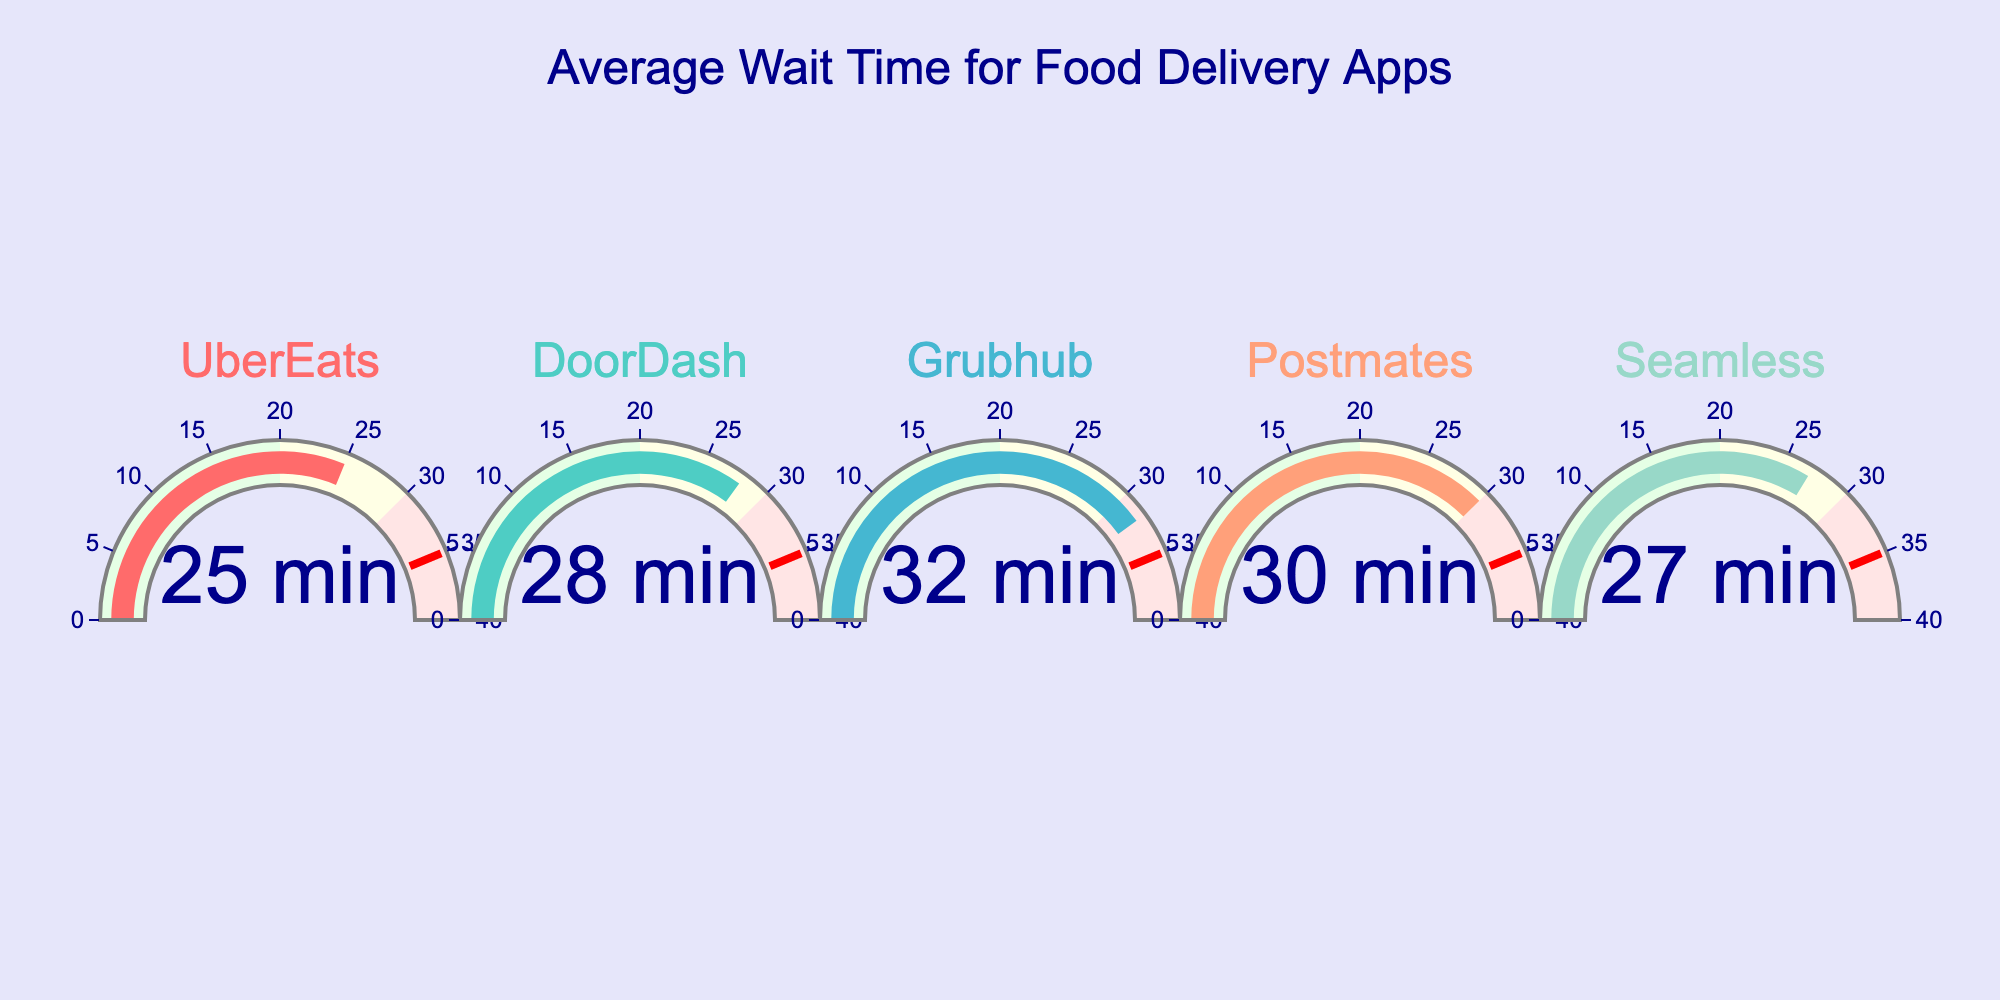What's the highest average wait time among the food delivery apps? The highest average wait time is the topmost number in the gauge chart. From the chart, Grubhub has the highest wait time at 32 minutes.
Answer: 32 minutes What's the average wait time for UberEats? The gauge chart shows the time directly. UberEats has an average wait time of 25 minutes.
Answer: 25 minutes Which app has the lowest average wait time? By comparing all the average wait times displayed on the gauges, UberEats has the lowest average wait time at 25 minutes.
Answer: UberEats How much longer is DoorDash's average wait time compared to Seamless? DoorDash has an average wait time of 28 minutes, and Seamless has an average wait time of 27 minutes. The difference is 28 - 27 = 1 minute.
Answer: 1 minute Is Grubhub's average wait time closer to DoorDash's or Postmates'? Grubhub has an average wait time of 32 minutes. DoorDash is at 28 minutes, and Postmates is at 30 minutes. The difference is 32 - 30 = 2 minutes (Postmates) and 32 - 28 = 4 minutes (DoorDash). Thus, Grubhub's wait time is closer to Postmates' at 2 minutes difference.
Answer: Postmates Which apps have an average wait time greater than 25 minutes? By reviewing the gauges, DoorDash at 28 minutes, Grubhub at 32 minutes, Postmates at 30 minutes, and Seamless at 27 minutes all have average wait times greater than 25 minutes.
Answer: DoorDash, Grubhub, Postmates, Seamless What's the average of the average wait times for all the apps? Sum all the average wait times (25 + 28 + 32 + 30 + 27) = 142. Then divide by the number of apps (5). The average is 142 / 5 = 28.4 minutes.
Answer: 28.4 minutes How many apps have an average wait time in the range of 30 to 40 minutes? Reviewing the gauges, Grubhub (32 minutes) and Postmates (30 minutes) both fall within the 30 to 40 minutes range. Hence, there are 2 such apps.
Answer: 2 apps 